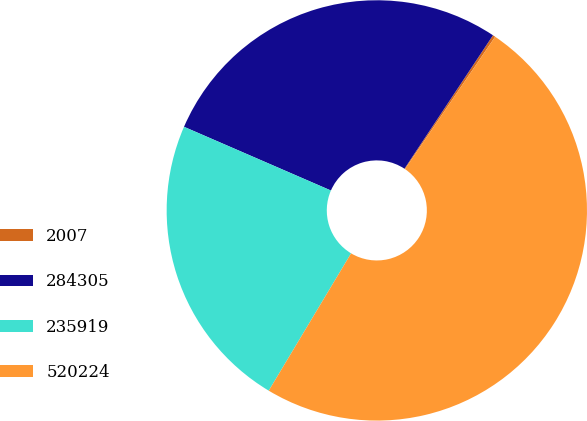Convert chart. <chart><loc_0><loc_0><loc_500><loc_500><pie_chart><fcel>2007<fcel>284305<fcel>235919<fcel>520224<nl><fcel>0.2%<fcel>27.81%<fcel>22.92%<fcel>49.08%<nl></chart> 